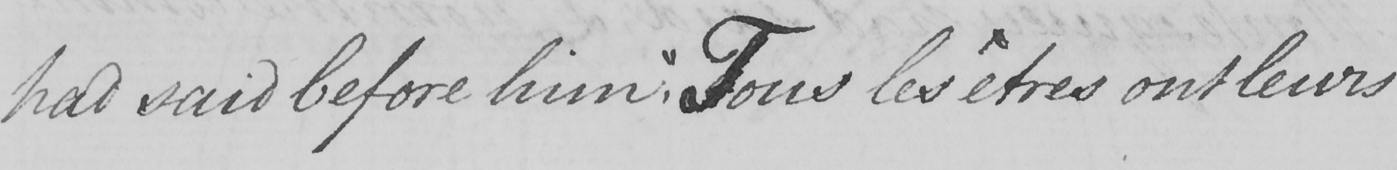What text is written in this handwritten line? had said before him ,  " Tous les êtres ont leurs 